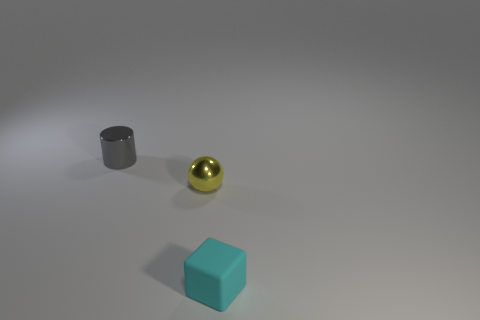Add 3 big blue spheres. How many objects exist? 6 Subtract all cubes. How many objects are left? 2 Subtract 0 blue blocks. How many objects are left? 3 Subtract all small yellow shiny balls. Subtract all small gray metal cylinders. How many objects are left? 1 Add 2 small cylinders. How many small cylinders are left? 3 Add 1 large purple metallic cylinders. How many large purple metallic cylinders exist? 1 